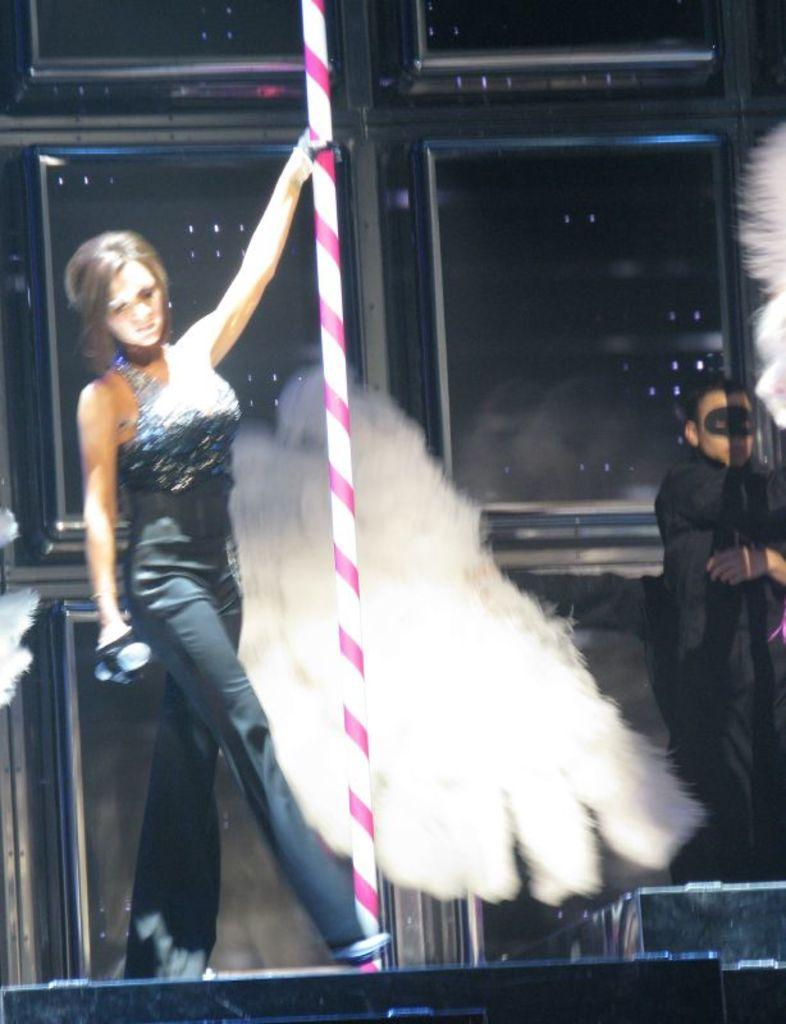Who is present in the image? There is a woman in the image. What is the woman doing in the image? The woman is standing in the image. What object is the woman holding in the image? The woman is holding a pipe in the image. Can you describe the person standing on the right side of the image? There is a person standing on the right side of the image, but no specific details are provided about them. How many cars are parked in front of the woman in the image? There is no mention of cars in the image, so it is impossible to determine how many cars are parked in front of the woman. 